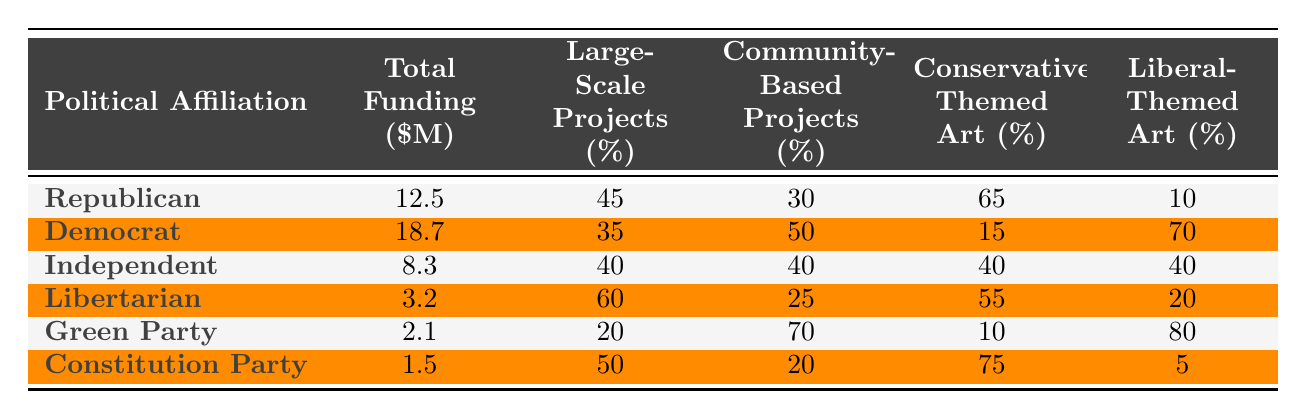What is the total funding allocated for Democrat projects? According to the table, the total funding for Democrat projects is listed as 18.7 million dollars.
Answer: 18.7 million dollars Which political affiliation has the largest percentage of funding allocated to Community-Based Projects? The Green Party has the highest percentage at 70%, which is the largest compared to other affiliations listed.
Answer: Green Party What percentage of Conservative-Themed Art is funded by the Constitution Party? The table states that 75% of the total funding from the Constitution Party is allocated to Conservative-Themed Art.
Answer: 75% What is the difference in total funding between the Republican and Libertarian political affiliations? The total funding for Republicans is 12.5 million dollars, and for Libertarians, it is 3.2 million dollars. The difference is 12.5 - 3.2 = 9.3 million dollars.
Answer: 9.3 million dollars Which political group has the lowest total funding, and what is that amount? The Constitution Party has the lowest total funding at 1.5 million dollars, which can be found in the table.
Answer: Constitution Party, 1.5 million dollars What percentage of funding for Independent projects goes toward Liberal-Themed Art? The table indicates that 40% of the funding for Independent projects is directed toward Liberal-Themed Art.
Answer: 40% If we sum the percentages of Large-Scale Projects across all political affiliations, what do we get? Adding the percentages: 45 (Republican) + 35 (Democrat) + 40 (Independent) + 60 (Libertarian) + 20 (Green Party) + 50 (Constitution Party) gives a total of 250%.
Answer: 250% Is it true that the funding allocation for large-scale projects is higher than 50% for any political affiliation? Yes, the Libertarian affiliation shows 60% funding for large-scale projects, confirming this statement is true.
Answer: Yes Which political affiliation allocates a higher percentage of its art funding to Conservative-Themed Art: the Republican or the Independent group? The Republican group allocates 65% and the Independent group allocates 40%. Since 65% is greater, Republicans prioritize Conservative-Themed Art more.
Answer: Republican group What is the average percentage of funding allocated to Liberal-Themed Art across all parties? To find the average, sum the percentages: 10 (Republican) + 70 (Democrat) + 40 (Independent) + 20 (Libertarian) + 80 (Green Party) + 5 (Constitution) = 225%, then divide by 6 parties, which equals 37.5%.
Answer: 37.5% 